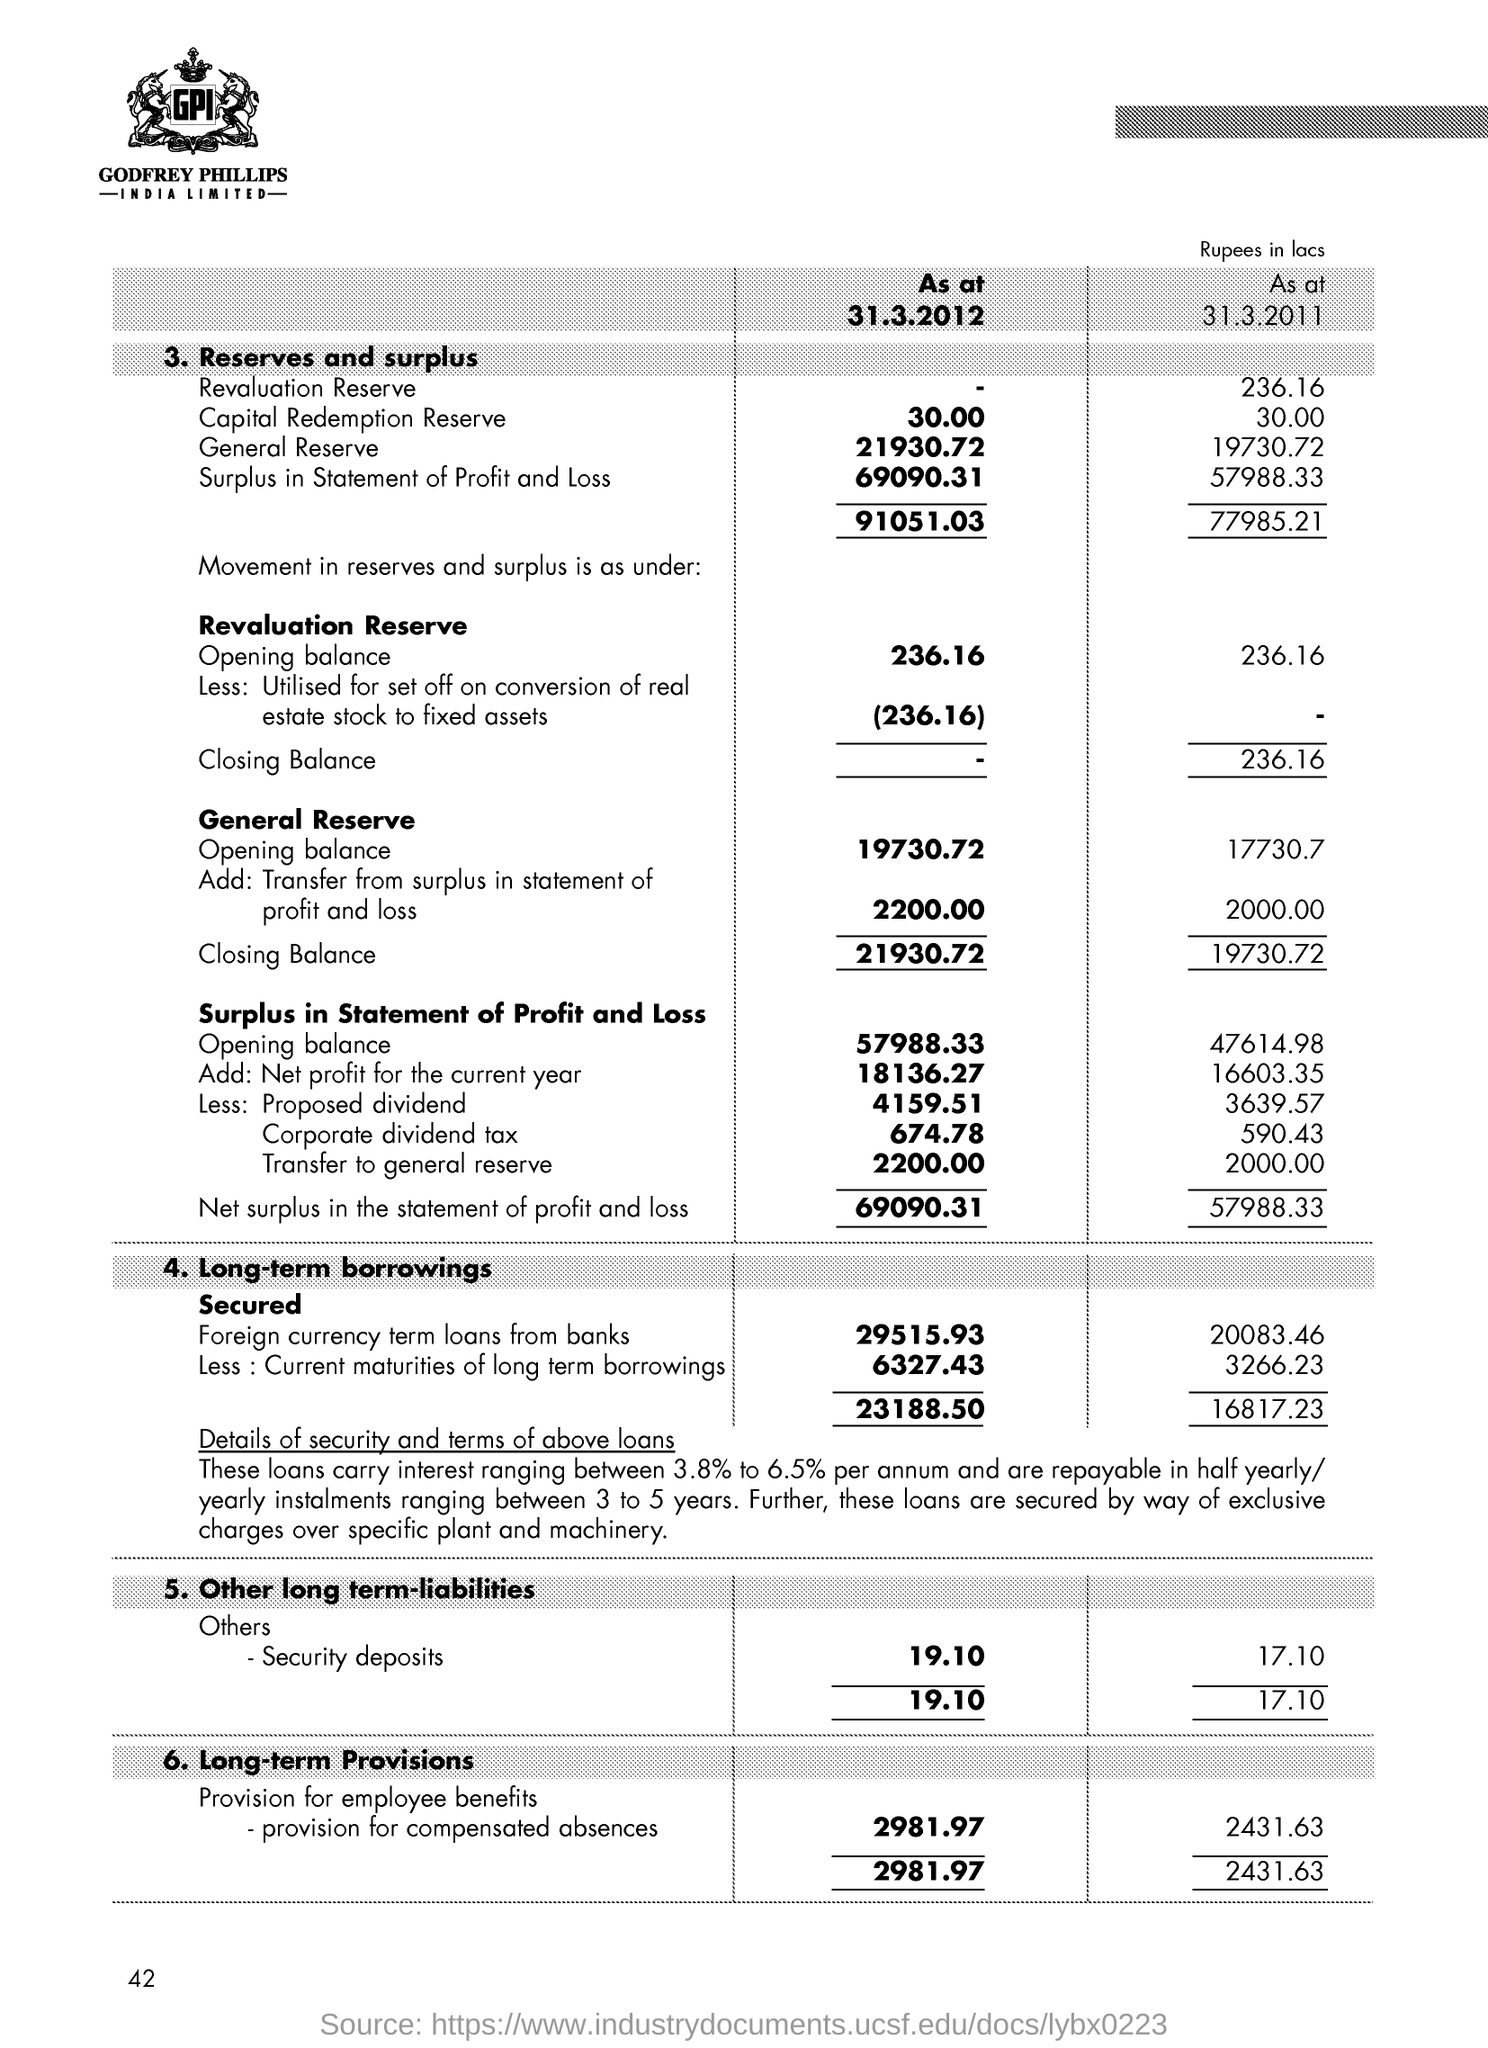Loans are secured by way of exclusive charges over which specific asset?
Ensure brevity in your answer.  Plant and machinery. What is the name of the company?
Your answer should be very brief. Godfrey Phillips India Limited. 